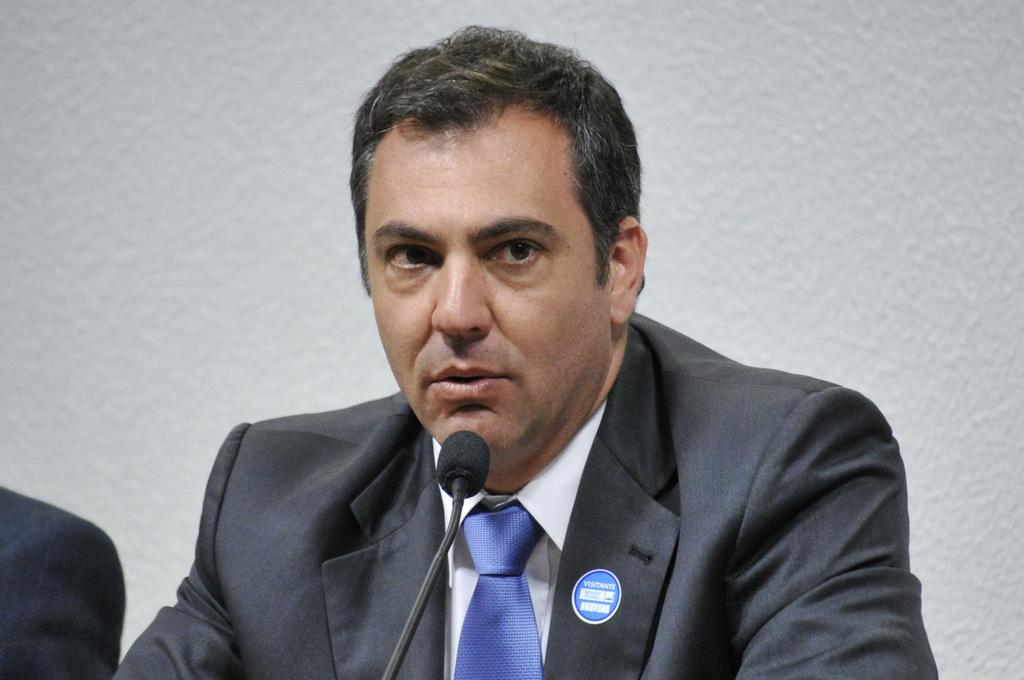What is the person in the image doing? The person is talking into a mic. What can be seen on the person's suit? The person has stickers on his suit. What is visible behind the person? There is a wall visible behind the person. What type of music is being played by the bulb in the image? There is no bulb present in the image, and therefore no music being played by a bulb. 